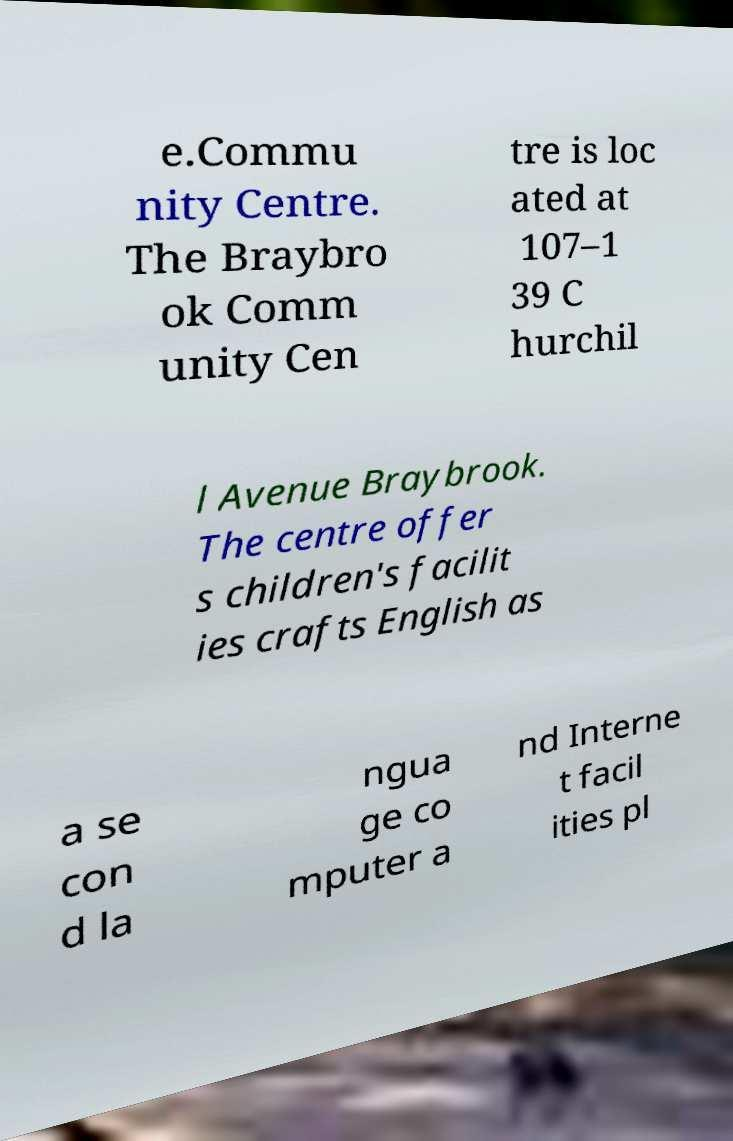I need the written content from this picture converted into text. Can you do that? e.Commu nity Centre. The Braybro ok Comm unity Cen tre is loc ated at 107–1 39 C hurchil l Avenue Braybrook. The centre offer s children's facilit ies crafts English as a se con d la ngua ge co mputer a nd Interne t facil ities pl 